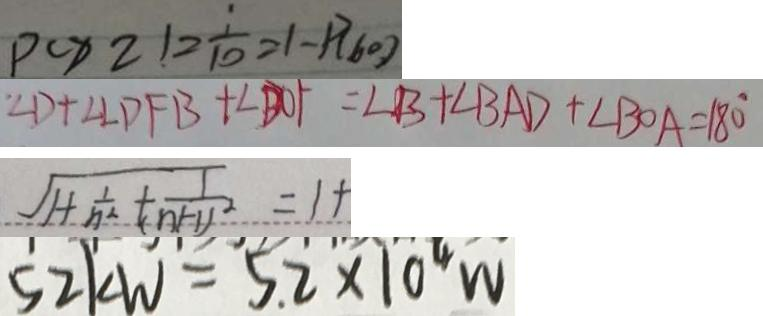Convert formula to latex. <formula><loc_0><loc_0><loc_500><loc_500>p ( x 2 ) 2 \frac { 1 } { 1 0 } = 1 - p ( 6 0 ) 
 \angle D + \angle \angle D F B + \angle B O F = \angle B + \angle B A D + \angle B O A = 1 8 0 ^ { \circ } 
 \sqrt { 1 + \frac { 1 } { n ^ { 2 } } + \frac { 1 } { ( n + 1 ) ^ { 2 } } } = 1 + 
 5 2 k W = 5 . 2 \times 1 0 ^ { 4 } W</formula> 